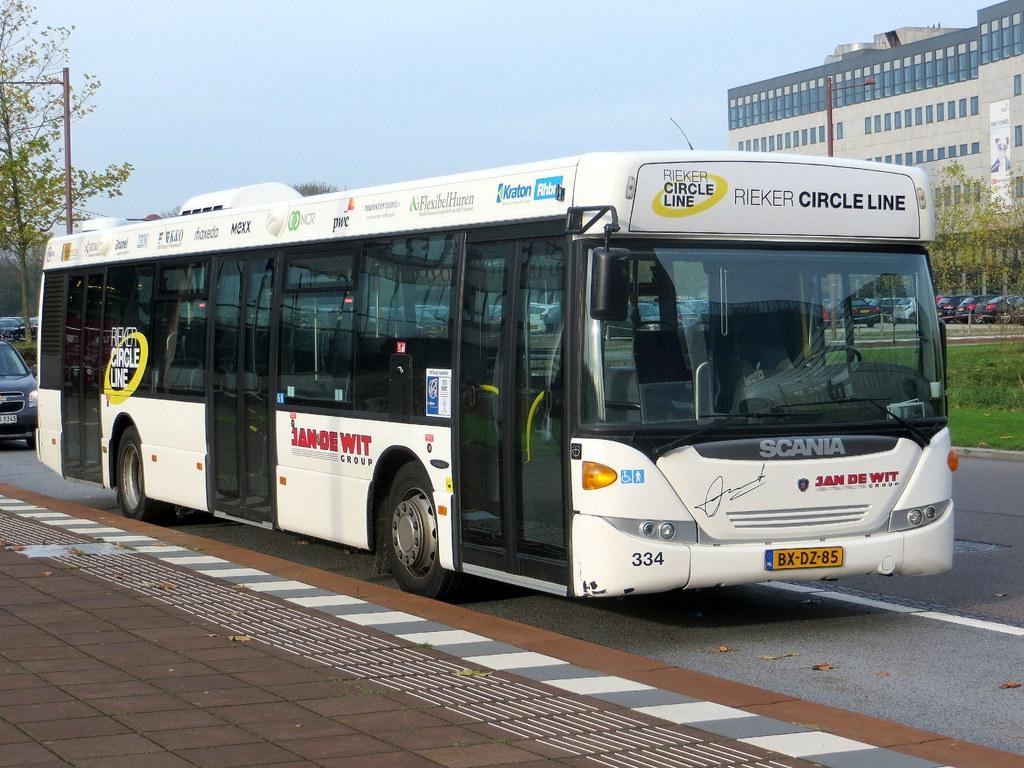<image>
Give a short and clear explanation of the subsequent image. A Rieker Circle Line transit bus is travelling on the road. 